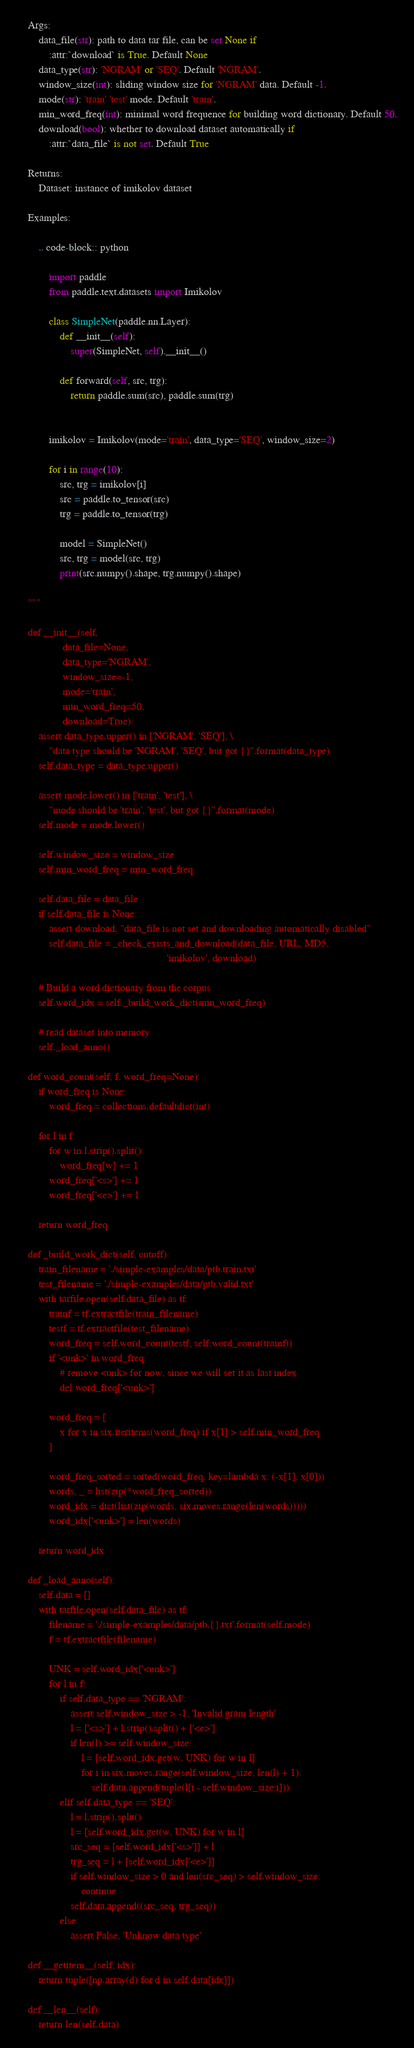Convert code to text. <code><loc_0><loc_0><loc_500><loc_500><_Python_>
    Args:
        data_file(str): path to data tar file, can be set None if
            :attr:`download` is True. Default None
        data_type(str): 'NGRAM' or 'SEQ'. Default 'NGRAM'.
        window_size(int): sliding window size for 'NGRAM' data. Default -1.
        mode(str): 'train' 'test' mode. Default 'train'.
        min_word_freq(int): minimal word frequence for building word dictionary. Default 50.
        download(bool): whether to download dataset automatically if
            :attr:`data_file` is not set. Default True

    Returns:
        Dataset: instance of imikolov dataset

    Examples:

        .. code-block:: python

            import paddle
            from paddle.text.datasets import Imikolov

            class SimpleNet(paddle.nn.Layer):
                def __init__(self):
                    super(SimpleNet, self).__init__()

                def forward(self, src, trg):
                    return paddle.sum(src), paddle.sum(trg)


            imikolov = Imikolov(mode='train', data_type='SEQ', window_size=2)

            for i in range(10):
                src, trg = imikolov[i]
                src = paddle.to_tensor(src)
                trg = paddle.to_tensor(trg)

                model = SimpleNet()
                src, trg = model(src, trg)
                print(src.numpy().shape, trg.numpy().shape)

    """

    def __init__(self,
                 data_file=None,
                 data_type='NGRAM',
                 window_size=-1,
                 mode='train',
                 min_word_freq=50,
                 download=True):
        assert data_type.upper() in ['NGRAM', 'SEQ'], \
            "data type should be 'NGRAM', 'SEQ', but got {}".format(data_type)
        self.data_type = data_type.upper()

        assert mode.lower() in ['train', 'test'], \
            "mode should be 'train', 'test', but got {}".format(mode)
        self.mode = mode.lower()

        self.window_size = window_size
        self.min_word_freq = min_word_freq

        self.data_file = data_file
        if self.data_file is None:
            assert download, "data_file is not set and downloading automatically disabled"
            self.data_file = _check_exists_and_download(data_file, URL, MD5,
                                                        'imikolov', download)

        # Build a word dictionary from the corpus
        self.word_idx = self._build_work_dict(min_word_freq)

        # read dataset into memory
        self._load_anno()

    def word_count(self, f, word_freq=None):
        if word_freq is None:
            word_freq = collections.defaultdict(int)

        for l in f:
            for w in l.strip().split():
                word_freq[w] += 1
            word_freq['<s>'] += 1
            word_freq['<e>'] += 1

        return word_freq

    def _build_work_dict(self, cutoff):
        train_filename = './simple-examples/data/ptb.train.txt'
        test_filename = './simple-examples/data/ptb.valid.txt'
        with tarfile.open(self.data_file) as tf:
            trainf = tf.extractfile(train_filename)
            testf = tf.extractfile(test_filename)
            word_freq = self.word_count(testf, self.word_count(trainf))
            if '<unk>' in word_freq:
                # remove <unk> for now, since we will set it as last index
                del word_freq['<unk>']

            word_freq = [
                x for x in six.iteritems(word_freq) if x[1] > self.min_word_freq
            ]

            word_freq_sorted = sorted(word_freq, key=lambda x: (-x[1], x[0]))
            words, _ = list(zip(*word_freq_sorted))
            word_idx = dict(list(zip(words, six.moves.range(len(words)))))
            word_idx['<unk>'] = len(words)

        return word_idx

    def _load_anno(self):
        self.data = []
        with tarfile.open(self.data_file) as tf:
            filename = './simple-examples/data/ptb.{}.txt'.format(self.mode)
            f = tf.extractfile(filename)

            UNK = self.word_idx['<unk>']
            for l in f:
                if self.data_type == 'NGRAM':
                    assert self.window_size > -1, 'Invalid gram length'
                    l = ['<s>'] + l.strip().split() + ['<e>']
                    if len(l) >= self.window_size:
                        l = [self.word_idx.get(w, UNK) for w in l]
                        for i in six.moves.range(self.window_size, len(l) + 1):
                            self.data.append(tuple(l[i - self.window_size:i]))
                elif self.data_type == 'SEQ':
                    l = l.strip().split()
                    l = [self.word_idx.get(w, UNK) for w in l]
                    src_seq = [self.word_idx['<s>']] + l
                    trg_seq = l + [self.word_idx['<e>']]
                    if self.window_size > 0 and len(src_seq) > self.window_size:
                        continue
                    self.data.append((src_seq, trg_seq))
                else:
                    assert False, 'Unknow data type'

    def __getitem__(self, idx):
        return tuple([np.array(d) for d in self.data[idx]])

    def __len__(self):
        return len(self.data)
</code> 